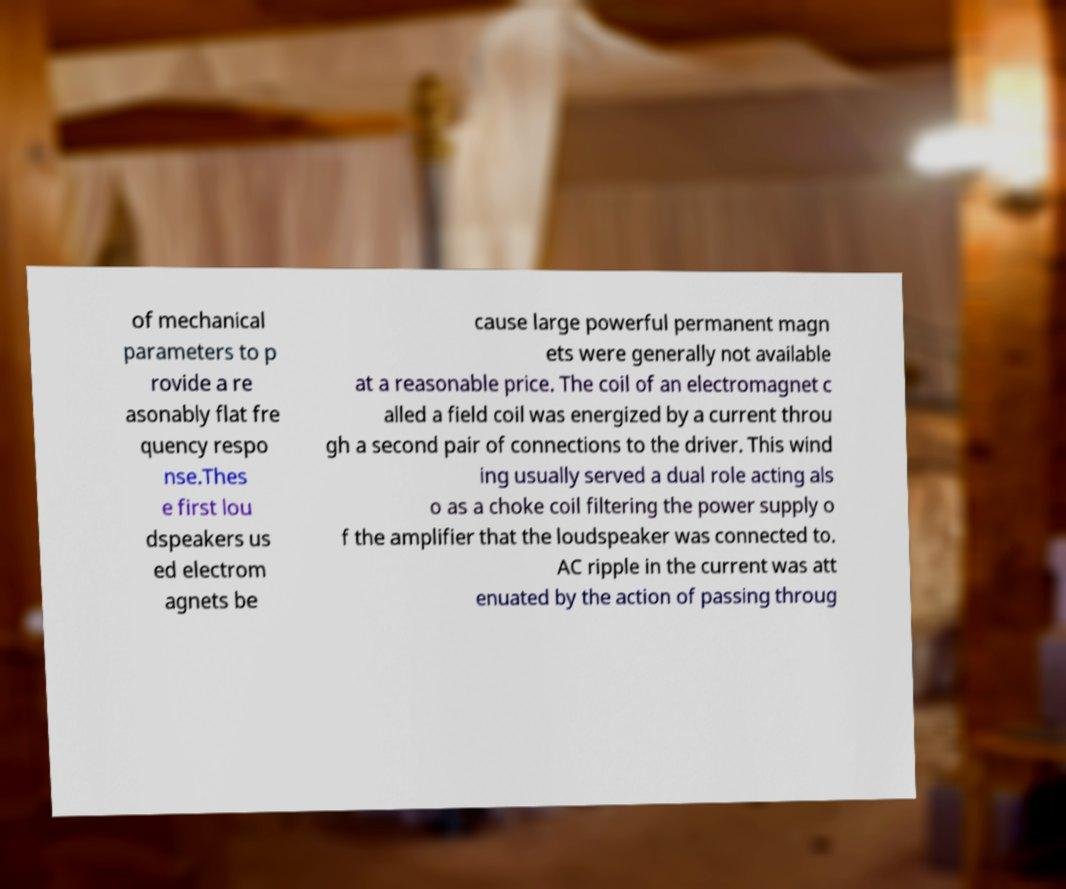Please identify and transcribe the text found in this image. of mechanical parameters to p rovide a re asonably flat fre quency respo nse.Thes e first lou dspeakers us ed electrom agnets be cause large powerful permanent magn ets were generally not available at a reasonable price. The coil of an electromagnet c alled a field coil was energized by a current throu gh a second pair of connections to the driver. This wind ing usually served a dual role acting als o as a choke coil filtering the power supply o f the amplifier that the loudspeaker was connected to. AC ripple in the current was att enuated by the action of passing throug 